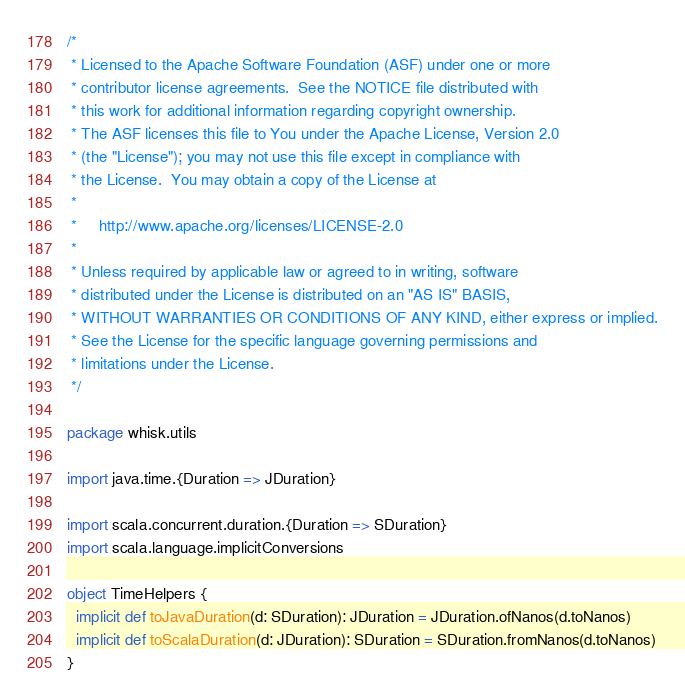Convert code to text. <code><loc_0><loc_0><loc_500><loc_500><_Scala_>/*
 * Licensed to the Apache Software Foundation (ASF) under one or more
 * contributor license agreements.  See the NOTICE file distributed with
 * this work for additional information regarding copyright ownership.
 * The ASF licenses this file to You under the Apache License, Version 2.0
 * (the "License"); you may not use this file except in compliance with
 * the License.  You may obtain a copy of the License at
 *
 *     http://www.apache.org/licenses/LICENSE-2.0
 *
 * Unless required by applicable law or agreed to in writing, software
 * distributed under the License is distributed on an "AS IS" BASIS,
 * WITHOUT WARRANTIES OR CONDITIONS OF ANY KIND, either express or implied.
 * See the License for the specific language governing permissions and
 * limitations under the License.
 */

package whisk.utils

import java.time.{Duration => JDuration}

import scala.concurrent.duration.{Duration => SDuration}
import scala.language.implicitConversions

object TimeHelpers {
  implicit def toJavaDuration(d: SDuration): JDuration = JDuration.ofNanos(d.toNanos)
  implicit def toScalaDuration(d: JDuration): SDuration = SDuration.fromNanos(d.toNanos)
}
</code> 